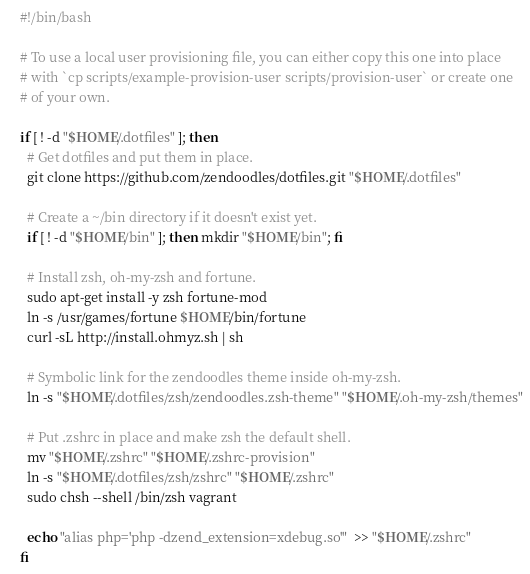Convert code to text. <code><loc_0><loc_0><loc_500><loc_500><_Bash_>#!/bin/bash

# To use a local user provisioning file, you can either copy this one into place
# with `cp scripts/example-provision-user scripts/provision-user` or create one
# of your own.

if [ ! -d "$HOME/.dotfiles" ]; then
  # Get dotfiles and put them in place.
  git clone https://github.com/zendoodles/dotfiles.git "$HOME/.dotfiles"

  # Create a ~/bin directory if it doesn't exist yet.
  if [ ! -d "$HOME/bin" ]; then mkdir "$HOME/bin"; fi

  # Install zsh, oh-my-zsh and fortune.
  sudo apt-get install -y zsh fortune-mod
  ln -s /usr/games/fortune $HOME/bin/fortune
  curl -sL http://install.ohmyz.sh | sh

  # Symbolic link for the zendoodles theme inside oh-my-zsh.
  ln -s "$HOME/.dotfiles/zsh/zendoodles.zsh-theme" "$HOME/.oh-my-zsh/themes"

  # Put .zshrc in place and make zsh the default shell.
  mv "$HOME/.zshrc" "$HOME/.zshrc-provision"
  ln -s "$HOME/.dotfiles/zsh/zshrc" "$HOME/.zshrc"
  sudo chsh --shell /bin/zsh vagrant

  echo "alias php='php -dzend_extension=xdebug.so'"  >> "$HOME/.zshrc"
fi
</code> 